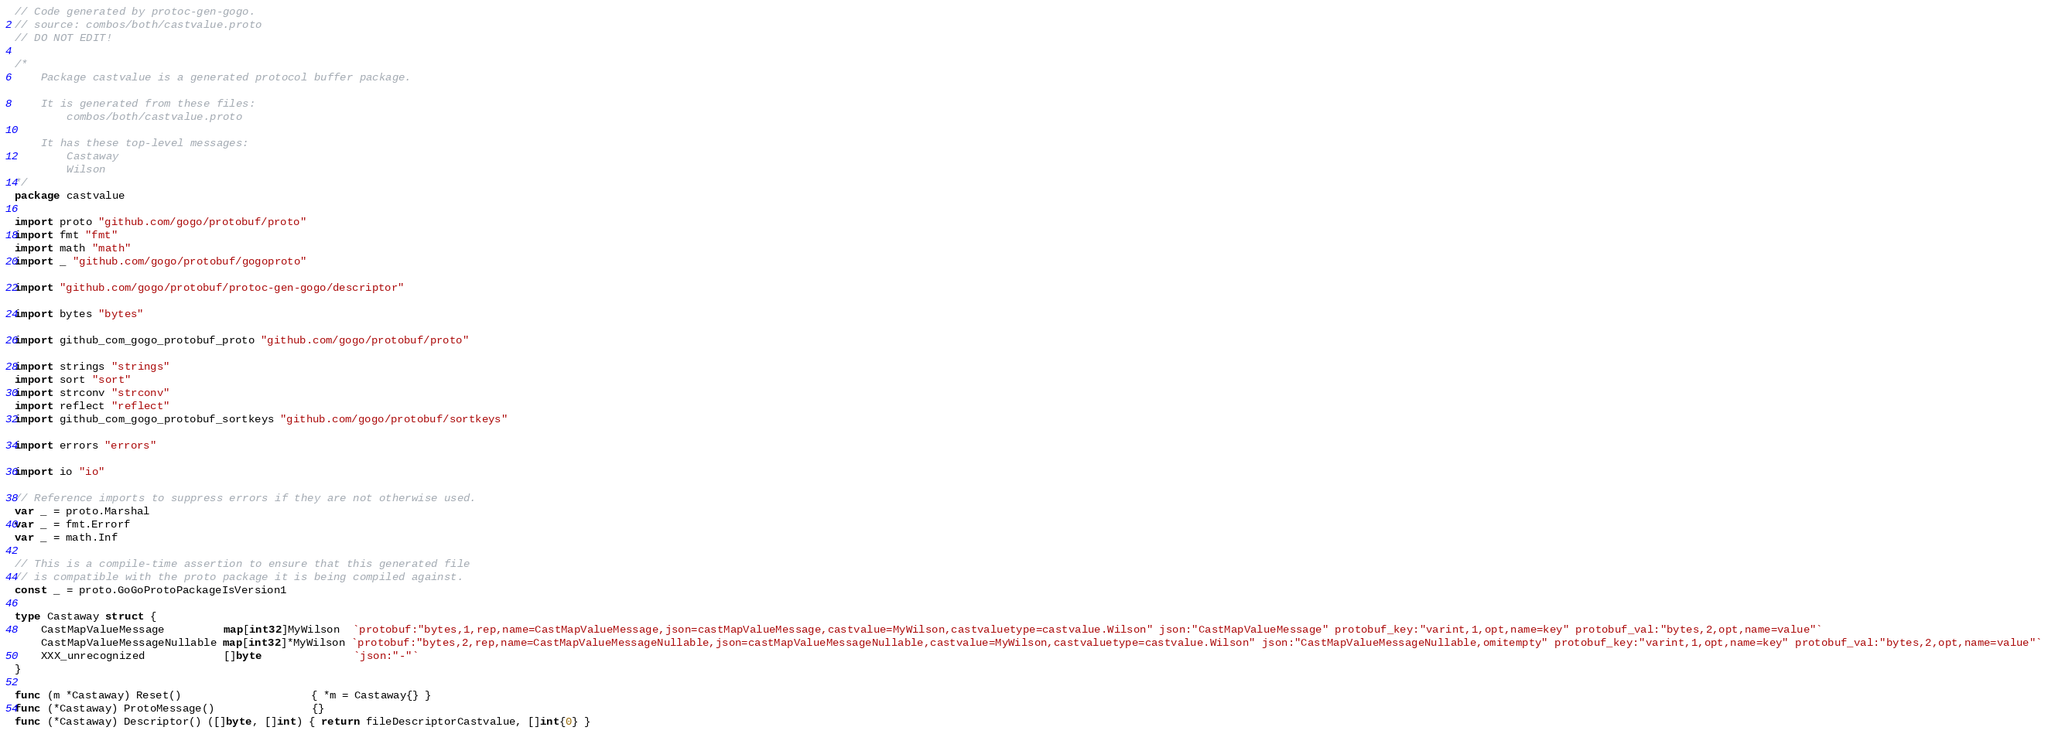<code> <loc_0><loc_0><loc_500><loc_500><_Go_>// Code generated by protoc-gen-gogo.
// source: combos/both/castvalue.proto
// DO NOT EDIT!

/*
	Package castvalue is a generated protocol buffer package.

	It is generated from these files:
		combos/both/castvalue.proto

	It has these top-level messages:
		Castaway
		Wilson
*/
package castvalue

import proto "github.com/gogo/protobuf/proto"
import fmt "fmt"
import math "math"
import _ "github.com/gogo/protobuf/gogoproto"

import "github.com/gogo/protobuf/protoc-gen-gogo/descriptor"

import bytes "bytes"

import github_com_gogo_protobuf_proto "github.com/gogo/protobuf/proto"

import strings "strings"
import sort "sort"
import strconv "strconv"
import reflect "reflect"
import github_com_gogo_protobuf_sortkeys "github.com/gogo/protobuf/sortkeys"

import errors "errors"

import io "io"

// Reference imports to suppress errors if they are not otherwise used.
var _ = proto.Marshal
var _ = fmt.Errorf
var _ = math.Inf

// This is a compile-time assertion to ensure that this generated file
// is compatible with the proto package it is being compiled against.
const _ = proto.GoGoProtoPackageIsVersion1

type Castaway struct {
	CastMapValueMessage         map[int32]MyWilson  `protobuf:"bytes,1,rep,name=CastMapValueMessage,json=castMapValueMessage,castvalue=MyWilson,castvaluetype=castvalue.Wilson" json:"CastMapValueMessage" protobuf_key:"varint,1,opt,name=key" protobuf_val:"bytes,2,opt,name=value"`
	CastMapValueMessageNullable map[int32]*MyWilson `protobuf:"bytes,2,rep,name=CastMapValueMessageNullable,json=castMapValueMessageNullable,castvalue=MyWilson,castvaluetype=castvalue.Wilson" json:"CastMapValueMessageNullable,omitempty" protobuf_key:"varint,1,opt,name=key" protobuf_val:"bytes,2,opt,name=value"`
	XXX_unrecognized            []byte              `json:"-"`
}

func (m *Castaway) Reset()                    { *m = Castaway{} }
func (*Castaway) ProtoMessage()               {}
func (*Castaway) Descriptor() ([]byte, []int) { return fileDescriptorCastvalue, []int{0} }
</code> 